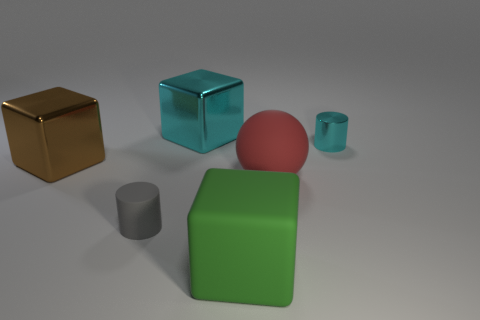Are there any other things that are the same material as the big cyan block?
Provide a short and direct response. Yes. There is a cyan object that is the same shape as the green rubber thing; what is it made of?
Offer a very short reply. Metal. How many other large metal things have the same shape as the big cyan metal object?
Ensure brevity in your answer.  1. What size is the red rubber object behind the large green object that is in front of the tiny gray matte cylinder?
Make the answer very short. Large. How many objects are either cylinders or yellow cubes?
Your answer should be compact. 2. Does the red rubber thing have the same shape as the tiny gray thing?
Your answer should be compact. No. Are there any large blocks made of the same material as the red object?
Offer a terse response. Yes. There is a large metallic object that is on the right side of the brown shiny object; is there a large metal block in front of it?
Your response must be concise. Yes. There is a cyan object to the left of the rubber sphere; does it have the same size as the tiny cyan cylinder?
Offer a very short reply. No. The cyan metallic cylinder has what size?
Offer a very short reply. Small. 